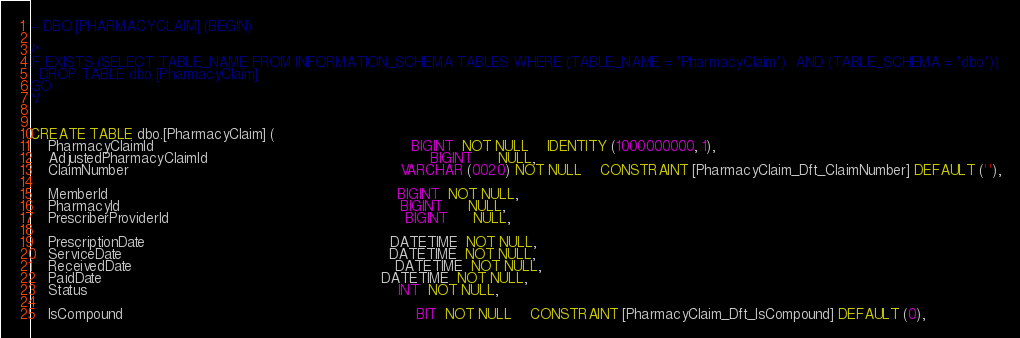<code> <loc_0><loc_0><loc_500><loc_500><_SQL_>-- DBO.[PHARMACYCLAIM] (BEGIN) 

/* 
IF EXISTS (SELECT TABLE_NAME FROM INFORMATION_SCHEMA.TABLES WHERE (TABLE_NAME = 'PharmacyClaim')  AND (TABLE_SCHEMA = 'dbo'))
  DROP TABLE dbo.[PharmacyClaim]
GO 
*/ 


CREATE TABLE dbo.[PharmacyClaim] (
    PharmacyClaimId                                                           BIGINT  NOT NULL    IDENTITY (1000000000, 1),
    AdjustedPharmacyClaimId                                                   BIGINT      NULL,
    ClaimNumber                                                              VARCHAR (0020) NOT NULL    CONSTRAINT [PharmacyClaim_Dft_ClaimNumber] DEFAULT (''),

    MemberId                                                                  BIGINT  NOT NULL,
    PharmacyId                                                                BIGINT      NULL,
    PrescriberProviderId                                                      BIGINT      NULL,

    PrescriptionDate                                                        DATETIME  NOT NULL,
    ServiceDate                                                             DATETIME  NOT NULL,
    ReceivedDate                                                            DATETIME  NOT NULL,
    PaidDate                                                                DATETIME  NOT NULL,
    Status                                                                       INT  NOT NULL,

    IsCompound                                                                   BIT  NOT NULL    CONSTRAINT [PharmacyClaim_Dft_IsCompound] DEFAULT (0),</code> 